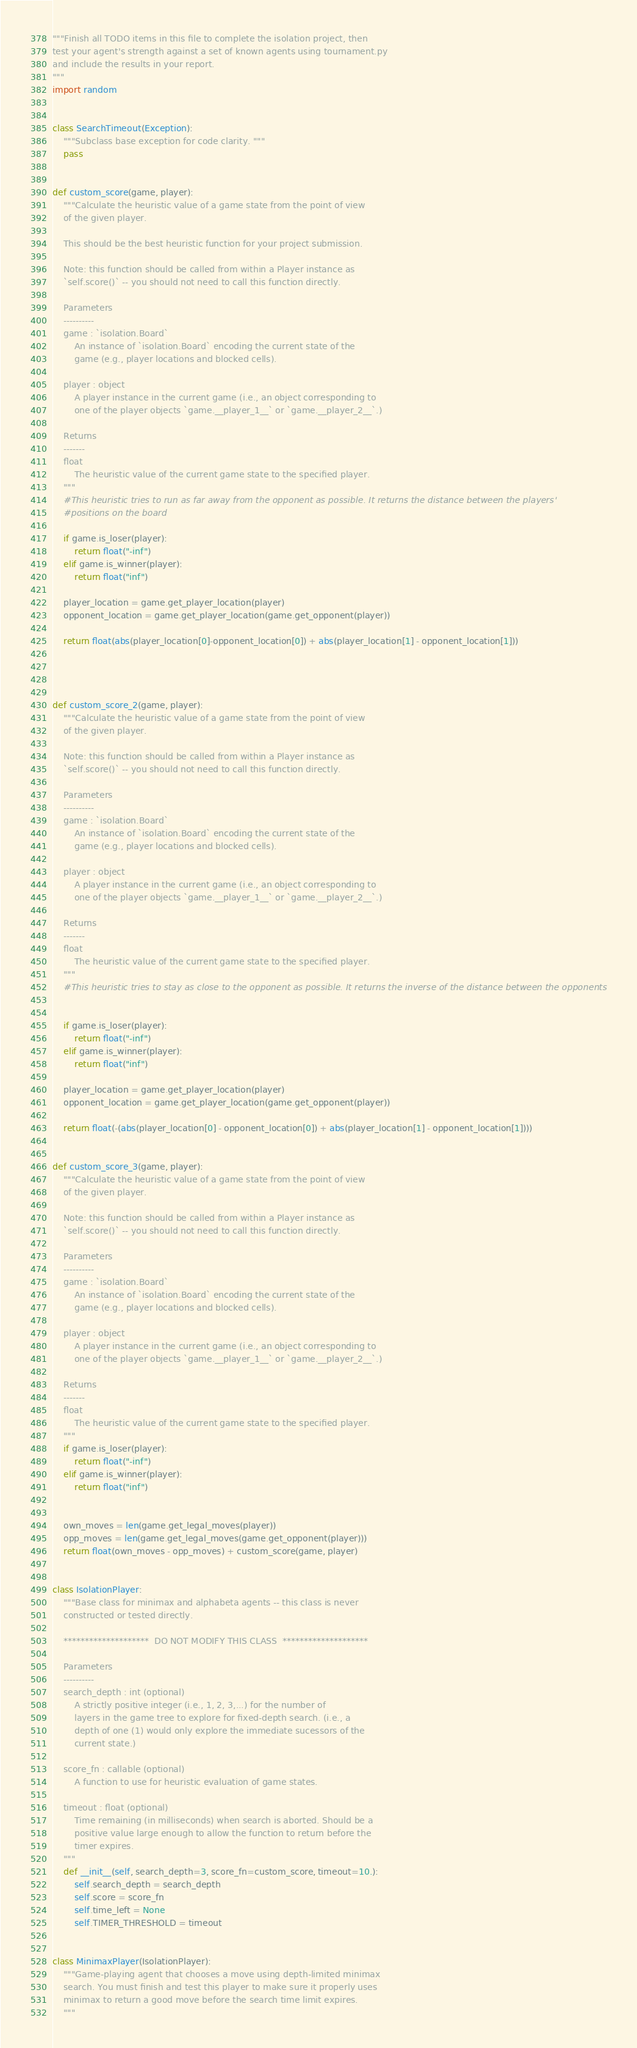<code> <loc_0><loc_0><loc_500><loc_500><_Python_>"""Finish all TODO items in this file to complete the isolation project, then
test your agent's strength against a set of known agents using tournament.py
and include the results in your report.
"""
import random


class SearchTimeout(Exception):
    """Subclass base exception for code clarity. """
    pass


def custom_score(game, player):
    """Calculate the heuristic value of a game state from the point of view
    of the given player.

    This should be the best heuristic function for your project submission.

    Note: this function should be called from within a Player instance as
    `self.score()` -- you should not need to call this function directly.

    Parameters
    ----------
    game : `isolation.Board`
        An instance of `isolation.Board` encoding the current state of the
        game (e.g., player locations and blocked cells).

    player : object
        A player instance in the current game (i.e., an object corresponding to
        one of the player objects `game.__player_1__` or `game.__player_2__`.)

    Returns
    -------
    float
        The heuristic value of the current game state to the specified player.
    """
    #This heuristic tries to run as far away from the opponent as possible. It returns the distance between the players'
    #positions on the board

    if game.is_loser(player):
        return float("-inf")
    elif game.is_winner(player):
        return float("inf")

    player_location = game.get_player_location(player)
    opponent_location = game.get_player_location(game.get_opponent(player))
    
    return float(abs(player_location[0]-opponent_location[0]) + abs(player_location[1] - opponent_location[1]))
    
        


def custom_score_2(game, player):
    """Calculate the heuristic value of a game state from the point of view
    of the given player.

    Note: this function should be called from within a Player instance as
    `self.score()` -- you should not need to call this function directly.

    Parameters
    ----------
    game : `isolation.Board`
        An instance of `isolation.Board` encoding the current state of the
        game (e.g., player locations and blocked cells).

    player : object
        A player instance in the current game (i.e., an object corresponding to
        one of the player objects `game.__player_1__` or `game.__player_2__`.)

    Returns
    -------
    float
        The heuristic value of the current game state to the specified player.
    """
    #This heuristic tries to stay as close to the opponent as possible. It returns the inverse of the distance between the opponents


    if game.is_loser(player):
        return float("-inf")
    elif game.is_winner(player):
        return float("inf")

    player_location = game.get_player_location(player)
    opponent_location = game.get_player_location(game.get_opponent(player))

    return float(-(abs(player_location[0] - opponent_location[0]) + abs(player_location[1] - opponent_location[1])))


def custom_score_3(game, player):
    """Calculate the heuristic value of a game state from the point of view
    of the given player.

    Note: this function should be called from within a Player instance as
    `self.score()` -- you should not need to call this function directly.

    Parameters
    ----------
    game : `isolation.Board`
        An instance of `isolation.Board` encoding the current state of the
        game (e.g., player locations and blocked cells).

    player : object
        A player instance in the current game (i.e., an object corresponding to
        one of the player objects `game.__player_1__` or `game.__player_2__`.)

    Returns
    -------
    float
        The heuristic value of the current game state to the specified player.
    """
    if game.is_loser(player):
        return float("-inf")
    elif game.is_winner(player):
        return float("inf")


    own_moves = len(game.get_legal_moves(player))
    opp_moves = len(game.get_legal_moves(game.get_opponent(player)))
    return float(own_moves - opp_moves) + custom_score(game, player)


class IsolationPlayer:
    """Base class for minimax and alphabeta agents -- this class is never
    constructed or tested directly.

    ********************  DO NOT MODIFY THIS CLASS  ********************

    Parameters
    ----------
    search_depth : int (optional)
        A strictly positive integer (i.e., 1, 2, 3,...) for the number of
        layers in the game tree to explore for fixed-depth search. (i.e., a
        depth of one (1) would only explore the immediate sucessors of the
        current state.)

    score_fn : callable (optional)
        A function to use for heuristic evaluation of game states.

    timeout : float (optional)
        Time remaining (in milliseconds) when search is aborted. Should be a
        positive value large enough to allow the function to return before the
        timer expires.
    """
    def __init__(self, search_depth=3, score_fn=custom_score, timeout=10.):
        self.search_depth = search_depth
        self.score = score_fn
        self.time_left = None
        self.TIMER_THRESHOLD = timeout


class MinimaxPlayer(IsolationPlayer):
    """Game-playing agent that chooses a move using depth-limited minimax
    search. You must finish and test this player to make sure it properly uses
    minimax to return a good move before the search time limit expires.
    """
</code> 